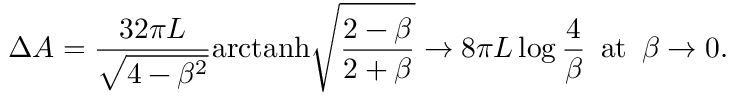Convert formula to latex. <formula><loc_0><loc_0><loc_500><loc_500>\Delta A = \frac { 3 2 \pi L } { \sqrt { 4 - \beta ^ { 2 } } } a r c t a n h \sqrt { \frac { 2 - \beta } { 2 + \beta } } \to 8 \pi L \log \frac { 4 } { \beta } \, a t \, \beta \to 0 .</formula> 